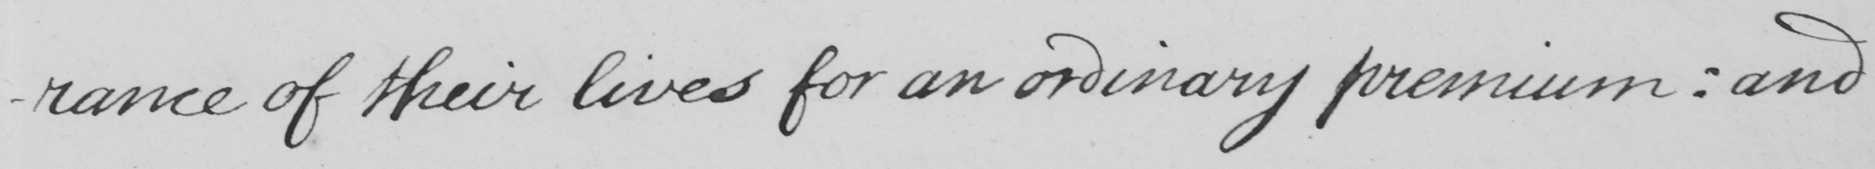Please provide the text content of this handwritten line. -rance of their lives for an ordinary premium :  and 